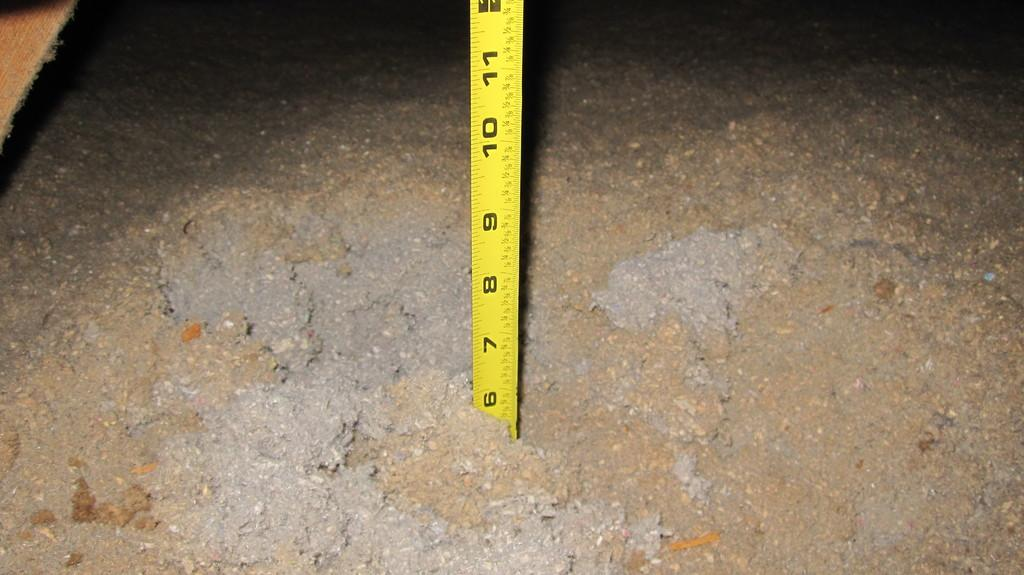Provide a one-sentence caption for the provided image. A tape measure is stuck in wet concrete at the six inch mark. 